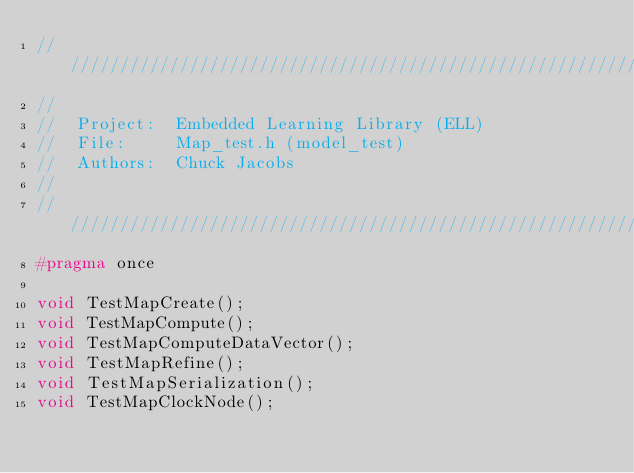Convert code to text. <code><loc_0><loc_0><loc_500><loc_500><_C_>////////////////////////////////////////////////////////////////////////////////////////////////////
//
//  Project:  Embedded Learning Library (ELL)
//  File:     Map_test.h (model_test)
//  Authors:  Chuck Jacobs
//
////////////////////////////////////////////////////////////////////////////////////////////////////
#pragma once

void TestMapCreate();
void TestMapCompute();
void TestMapComputeDataVector();
void TestMapRefine();
void TestMapSerialization();
void TestMapClockNode();
</code> 